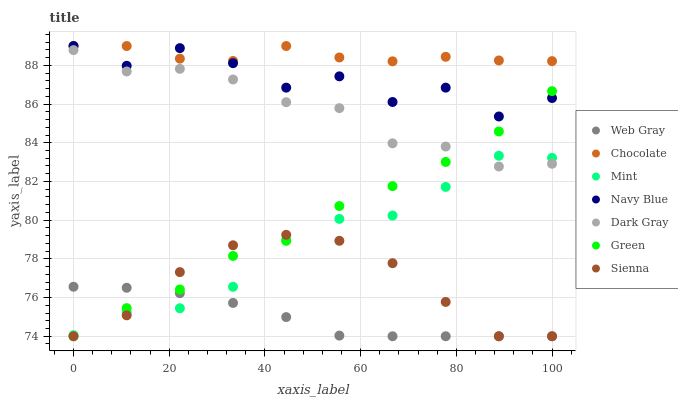Does Web Gray have the minimum area under the curve?
Answer yes or no. Yes. Does Chocolate have the maximum area under the curve?
Answer yes or no. Yes. Does Navy Blue have the minimum area under the curve?
Answer yes or no. No. Does Navy Blue have the maximum area under the curve?
Answer yes or no. No. Is Web Gray the smoothest?
Answer yes or no. Yes. Is Navy Blue the roughest?
Answer yes or no. Yes. Is Navy Blue the smoothest?
Answer yes or no. No. Is Web Gray the roughest?
Answer yes or no. No. Does Sienna have the lowest value?
Answer yes or no. Yes. Does Navy Blue have the lowest value?
Answer yes or no. No. Does Chocolate have the highest value?
Answer yes or no. Yes. Does Web Gray have the highest value?
Answer yes or no. No. Is Web Gray less than Navy Blue?
Answer yes or no. Yes. Is Dark Gray greater than Web Gray?
Answer yes or no. Yes. Does Sienna intersect Mint?
Answer yes or no. Yes. Is Sienna less than Mint?
Answer yes or no. No. Is Sienna greater than Mint?
Answer yes or no. No. Does Web Gray intersect Navy Blue?
Answer yes or no. No. 